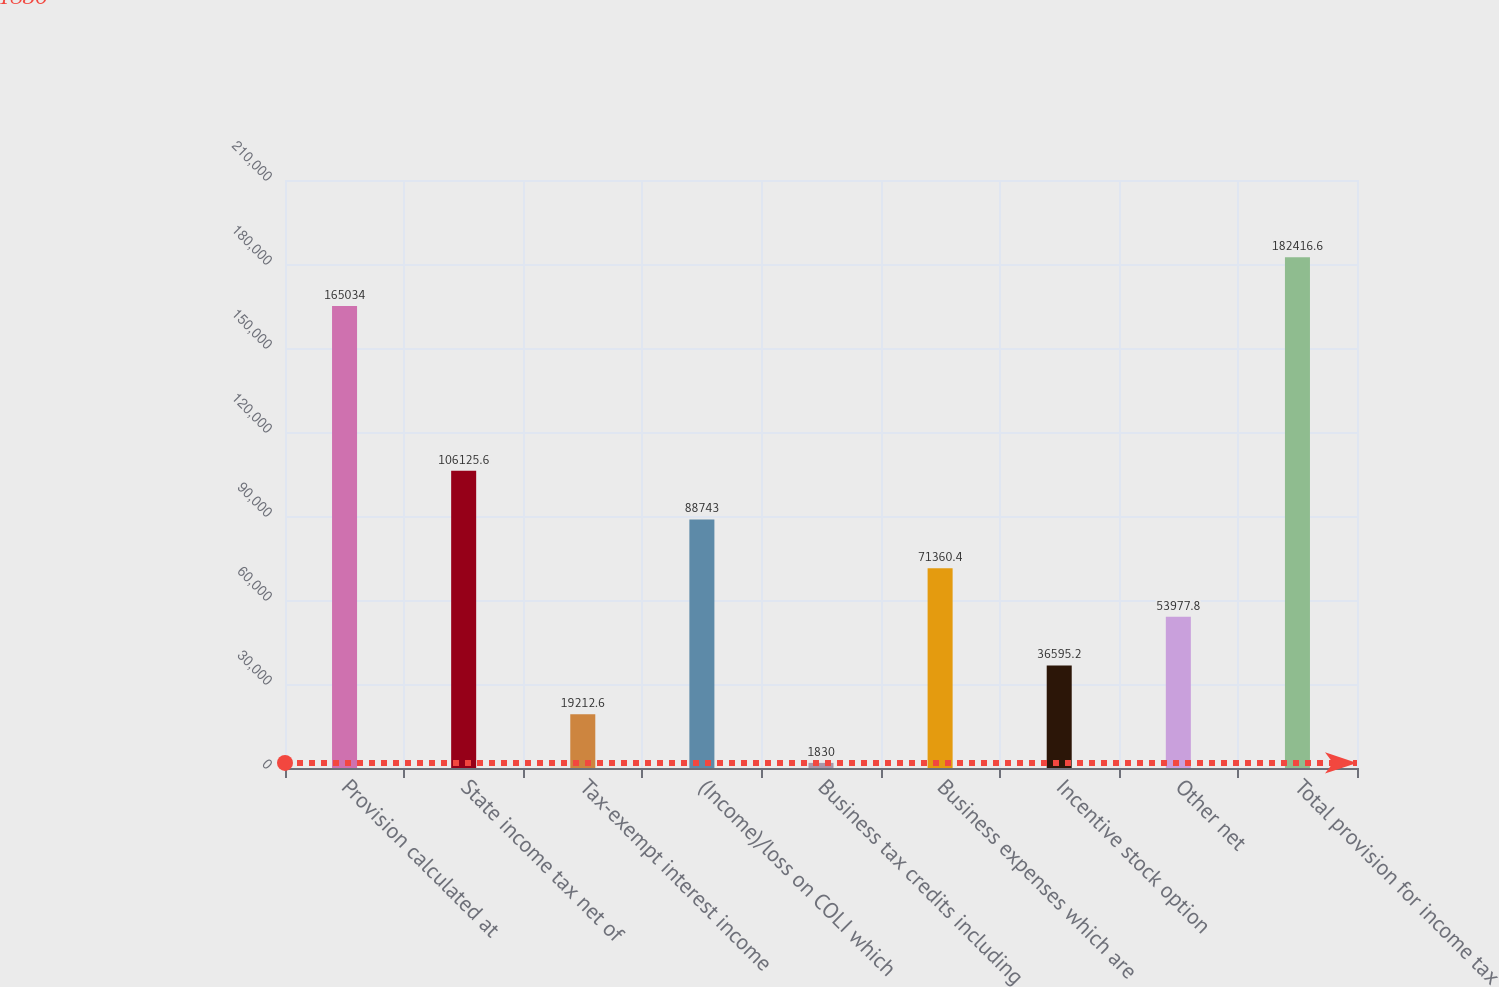<chart> <loc_0><loc_0><loc_500><loc_500><bar_chart><fcel>Provision calculated at<fcel>State income tax net of<fcel>Tax-exempt interest income<fcel>(Income)/loss on COLI which<fcel>Business tax credits including<fcel>Business expenses which are<fcel>Incentive stock option<fcel>Other net<fcel>Total provision for income tax<nl><fcel>165034<fcel>106126<fcel>19212.6<fcel>88743<fcel>1830<fcel>71360.4<fcel>36595.2<fcel>53977.8<fcel>182417<nl></chart> 